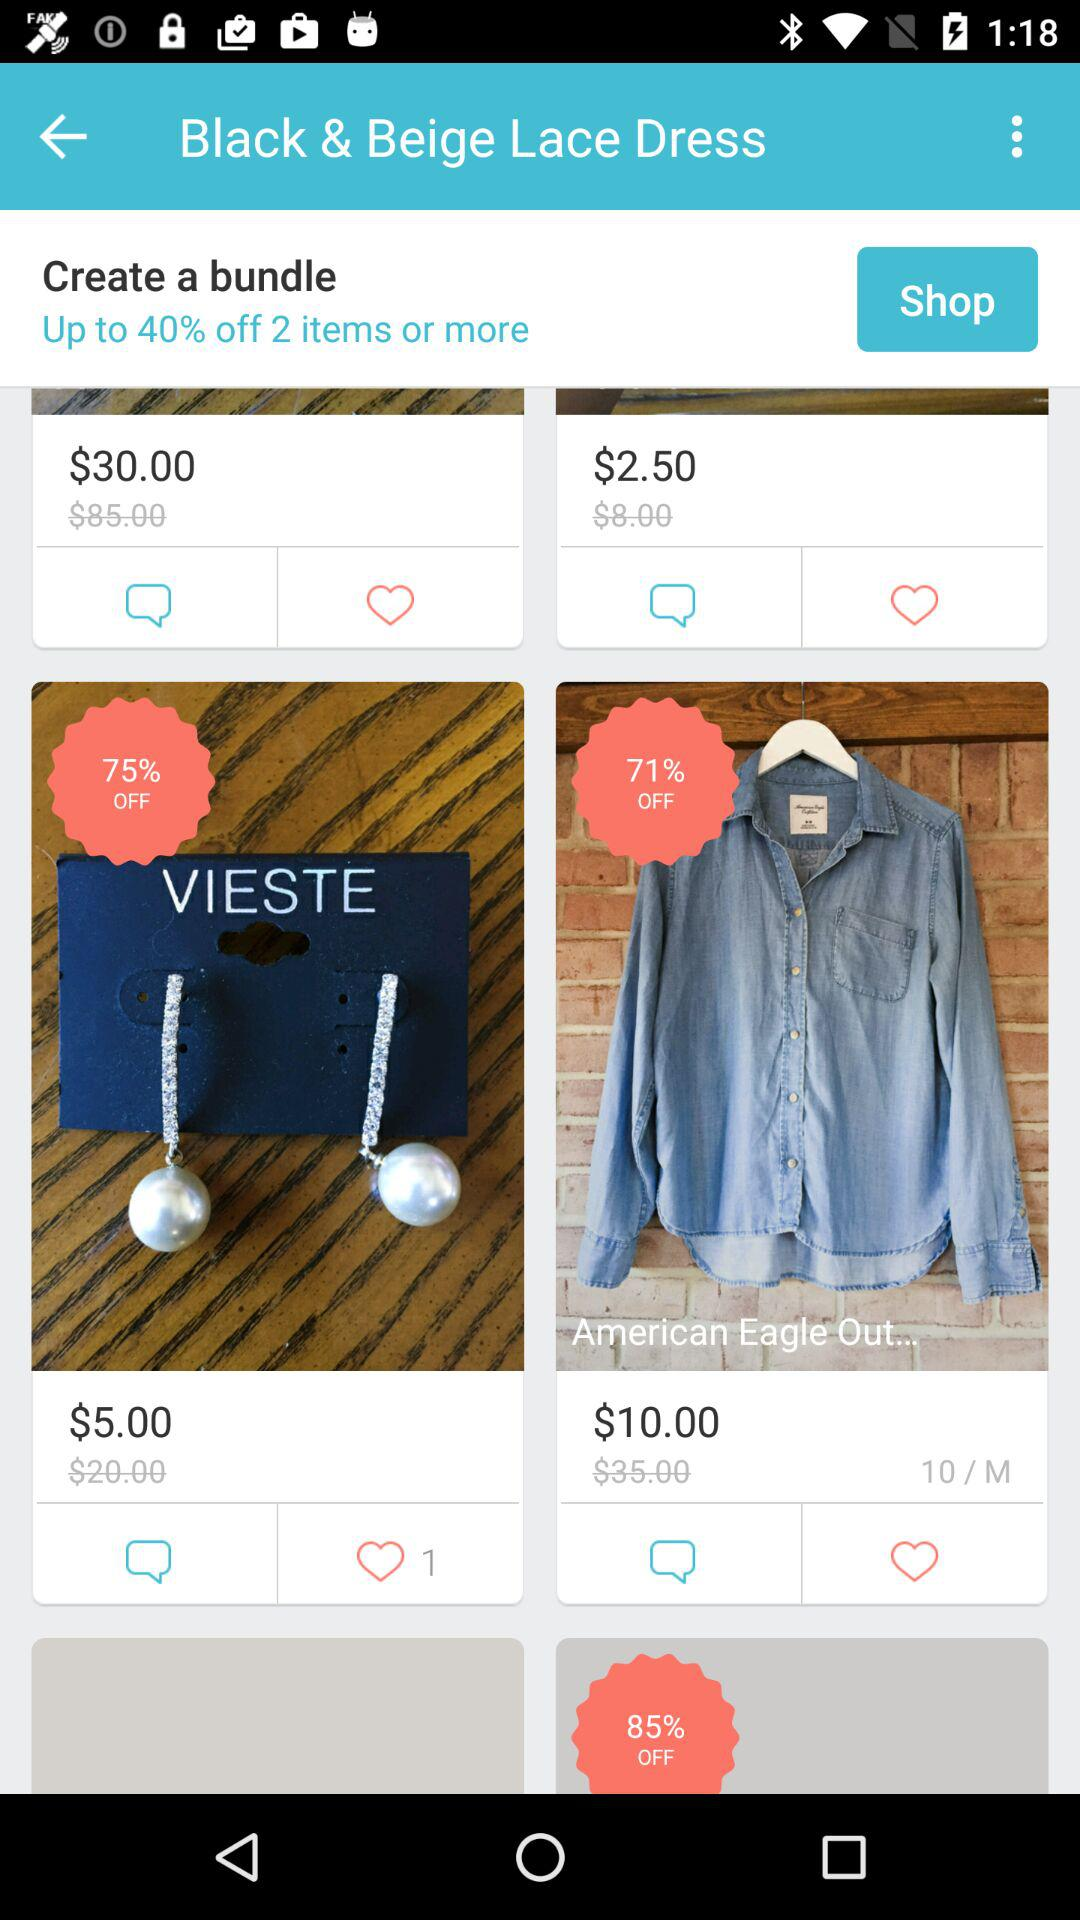How much of a discount can we get on the "American Eagle" item? You can get 71% off on the "American Eagle" item. 